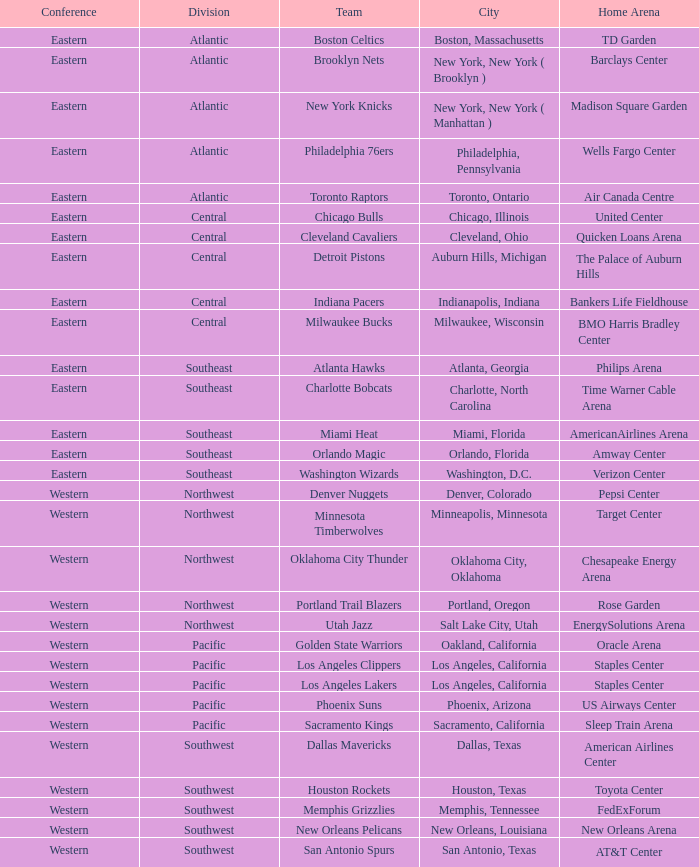Which conference is in Portland, Oregon? Western. Parse the full table. {'header': ['Conference', 'Division', 'Team', 'City', 'Home Arena'], 'rows': [['Eastern', 'Atlantic', 'Boston Celtics', 'Boston, Massachusetts', 'TD Garden'], ['Eastern', 'Atlantic', 'Brooklyn Nets', 'New York, New York ( Brooklyn )', 'Barclays Center'], ['Eastern', 'Atlantic', 'New York Knicks', 'New York, New York ( Manhattan )', 'Madison Square Garden'], ['Eastern', 'Atlantic', 'Philadelphia 76ers', 'Philadelphia, Pennsylvania', 'Wells Fargo Center'], ['Eastern', 'Atlantic', 'Toronto Raptors', 'Toronto, Ontario', 'Air Canada Centre'], ['Eastern', 'Central', 'Chicago Bulls', 'Chicago, Illinois', 'United Center'], ['Eastern', 'Central', 'Cleveland Cavaliers', 'Cleveland, Ohio', 'Quicken Loans Arena'], ['Eastern', 'Central', 'Detroit Pistons', 'Auburn Hills, Michigan', 'The Palace of Auburn Hills'], ['Eastern', 'Central', 'Indiana Pacers', 'Indianapolis, Indiana', 'Bankers Life Fieldhouse'], ['Eastern', 'Central', 'Milwaukee Bucks', 'Milwaukee, Wisconsin', 'BMO Harris Bradley Center'], ['Eastern', 'Southeast', 'Atlanta Hawks', 'Atlanta, Georgia', 'Philips Arena'], ['Eastern', 'Southeast', 'Charlotte Bobcats', 'Charlotte, North Carolina', 'Time Warner Cable Arena'], ['Eastern', 'Southeast', 'Miami Heat', 'Miami, Florida', 'AmericanAirlines Arena'], ['Eastern', 'Southeast', 'Orlando Magic', 'Orlando, Florida', 'Amway Center'], ['Eastern', 'Southeast', 'Washington Wizards', 'Washington, D.C.', 'Verizon Center'], ['Western', 'Northwest', 'Denver Nuggets', 'Denver, Colorado', 'Pepsi Center'], ['Western', 'Northwest', 'Minnesota Timberwolves', 'Minneapolis, Minnesota', 'Target Center'], ['Western', 'Northwest', 'Oklahoma City Thunder', 'Oklahoma City, Oklahoma', 'Chesapeake Energy Arena'], ['Western', 'Northwest', 'Portland Trail Blazers', 'Portland, Oregon', 'Rose Garden'], ['Western', 'Northwest', 'Utah Jazz', 'Salt Lake City, Utah', 'EnergySolutions Arena'], ['Western', 'Pacific', 'Golden State Warriors', 'Oakland, California', 'Oracle Arena'], ['Western', 'Pacific', 'Los Angeles Clippers', 'Los Angeles, California', 'Staples Center'], ['Western', 'Pacific', 'Los Angeles Lakers', 'Los Angeles, California', 'Staples Center'], ['Western', 'Pacific', 'Phoenix Suns', 'Phoenix, Arizona', 'US Airways Center'], ['Western', 'Pacific', 'Sacramento Kings', 'Sacramento, California', 'Sleep Train Arena'], ['Western', 'Southwest', 'Dallas Mavericks', 'Dallas, Texas', 'American Airlines Center'], ['Western', 'Southwest', 'Houston Rockets', 'Houston, Texas', 'Toyota Center'], ['Western', 'Southwest', 'Memphis Grizzlies', 'Memphis, Tennessee', 'FedExForum'], ['Western', 'Southwest', 'New Orleans Pelicans', 'New Orleans, Louisiana', 'New Orleans Arena'], ['Western', 'Southwest', 'San Antonio Spurs', 'San Antonio, Texas', 'AT&T Center']]} 